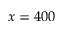Convert formula to latex. <formula><loc_0><loc_0><loc_500><loc_500>x = 4 0 0</formula> 